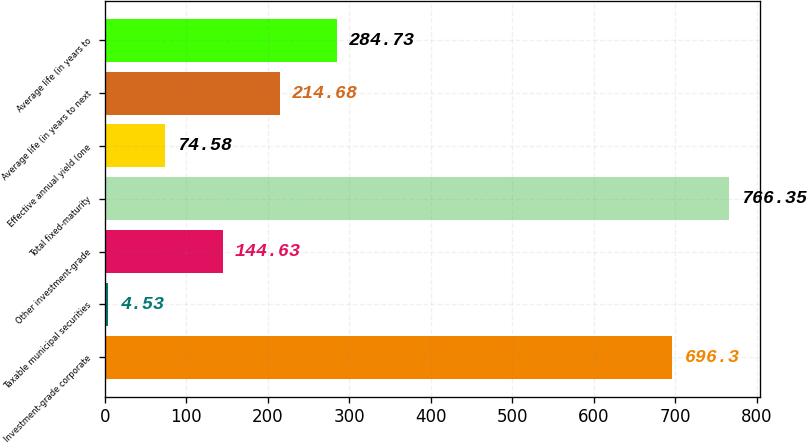Convert chart to OTSL. <chart><loc_0><loc_0><loc_500><loc_500><bar_chart><fcel>Investment-grade corporate<fcel>Taxable municipal securities<fcel>Other investment-grade<fcel>Total fixed-maturity<fcel>Effective annual yield (one<fcel>Average life (in years to next<fcel>Average life (in years to<nl><fcel>696.3<fcel>4.53<fcel>144.63<fcel>766.35<fcel>74.58<fcel>214.68<fcel>284.73<nl></chart> 